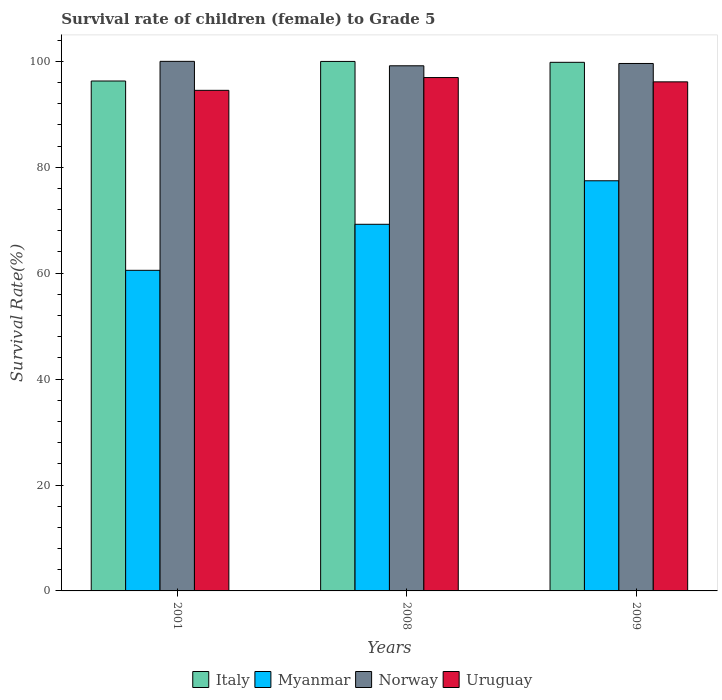How many groups of bars are there?
Your answer should be compact. 3. Are the number of bars per tick equal to the number of legend labels?
Keep it short and to the point. Yes. How many bars are there on the 2nd tick from the left?
Offer a very short reply. 4. How many bars are there on the 1st tick from the right?
Provide a succinct answer. 4. What is the label of the 3rd group of bars from the left?
Ensure brevity in your answer.  2009. In how many cases, is the number of bars for a given year not equal to the number of legend labels?
Provide a short and direct response. 0. What is the survival rate of female children to grade 5 in Uruguay in 2009?
Provide a short and direct response. 96.13. Across all years, what is the maximum survival rate of female children to grade 5 in Italy?
Your answer should be compact. 99.99. Across all years, what is the minimum survival rate of female children to grade 5 in Italy?
Keep it short and to the point. 96.29. In which year was the survival rate of female children to grade 5 in Myanmar maximum?
Your answer should be compact. 2009. In which year was the survival rate of female children to grade 5 in Uruguay minimum?
Ensure brevity in your answer.  2001. What is the total survival rate of female children to grade 5 in Italy in the graph?
Your response must be concise. 296.09. What is the difference between the survival rate of female children to grade 5 in Uruguay in 2001 and that in 2008?
Give a very brief answer. -2.41. What is the difference between the survival rate of female children to grade 5 in Norway in 2008 and the survival rate of female children to grade 5 in Uruguay in 2009?
Give a very brief answer. 3.04. What is the average survival rate of female children to grade 5 in Norway per year?
Give a very brief answer. 99.59. In the year 2001, what is the difference between the survival rate of female children to grade 5 in Italy and survival rate of female children to grade 5 in Uruguay?
Keep it short and to the point. 1.76. In how many years, is the survival rate of female children to grade 5 in Italy greater than 52 %?
Your answer should be very brief. 3. What is the ratio of the survival rate of female children to grade 5 in Italy in 2008 to that in 2009?
Offer a very short reply. 1. Is the survival rate of female children to grade 5 in Italy in 2008 less than that in 2009?
Your answer should be compact. No. Is the difference between the survival rate of female children to grade 5 in Italy in 2008 and 2009 greater than the difference between the survival rate of female children to grade 5 in Uruguay in 2008 and 2009?
Your answer should be very brief. No. What is the difference between the highest and the second highest survival rate of female children to grade 5 in Italy?
Provide a succinct answer. 0.17. What is the difference between the highest and the lowest survival rate of female children to grade 5 in Norway?
Your answer should be compact. 0.84. Is the sum of the survival rate of female children to grade 5 in Norway in 2001 and 2008 greater than the maximum survival rate of female children to grade 5 in Italy across all years?
Provide a short and direct response. Yes. What does the 2nd bar from the left in 2008 represents?
Your answer should be compact. Myanmar. What does the 4th bar from the right in 2009 represents?
Ensure brevity in your answer.  Italy. Is it the case that in every year, the sum of the survival rate of female children to grade 5 in Uruguay and survival rate of female children to grade 5 in Norway is greater than the survival rate of female children to grade 5 in Myanmar?
Offer a terse response. Yes. How many bars are there?
Your answer should be very brief. 12. Where does the legend appear in the graph?
Your response must be concise. Bottom center. How are the legend labels stacked?
Keep it short and to the point. Horizontal. What is the title of the graph?
Make the answer very short. Survival rate of children (female) to Grade 5. What is the label or title of the Y-axis?
Make the answer very short. Survival Rate(%). What is the Survival Rate(%) in Italy in 2001?
Your answer should be compact. 96.29. What is the Survival Rate(%) in Myanmar in 2001?
Provide a succinct answer. 60.54. What is the Survival Rate(%) in Uruguay in 2001?
Keep it short and to the point. 94.53. What is the Survival Rate(%) in Italy in 2008?
Offer a terse response. 99.99. What is the Survival Rate(%) in Myanmar in 2008?
Your answer should be very brief. 69.23. What is the Survival Rate(%) in Norway in 2008?
Give a very brief answer. 99.16. What is the Survival Rate(%) in Uruguay in 2008?
Offer a terse response. 96.94. What is the Survival Rate(%) in Italy in 2009?
Keep it short and to the point. 99.82. What is the Survival Rate(%) of Myanmar in 2009?
Your answer should be very brief. 77.45. What is the Survival Rate(%) of Norway in 2009?
Keep it short and to the point. 99.6. What is the Survival Rate(%) of Uruguay in 2009?
Your answer should be very brief. 96.13. Across all years, what is the maximum Survival Rate(%) of Italy?
Offer a terse response. 99.99. Across all years, what is the maximum Survival Rate(%) in Myanmar?
Keep it short and to the point. 77.45. Across all years, what is the maximum Survival Rate(%) in Norway?
Offer a terse response. 100. Across all years, what is the maximum Survival Rate(%) in Uruguay?
Your response must be concise. 96.94. Across all years, what is the minimum Survival Rate(%) in Italy?
Provide a short and direct response. 96.29. Across all years, what is the minimum Survival Rate(%) of Myanmar?
Your answer should be very brief. 60.54. Across all years, what is the minimum Survival Rate(%) in Norway?
Offer a terse response. 99.16. Across all years, what is the minimum Survival Rate(%) in Uruguay?
Make the answer very short. 94.53. What is the total Survival Rate(%) of Italy in the graph?
Make the answer very short. 296.09. What is the total Survival Rate(%) of Myanmar in the graph?
Your answer should be very brief. 207.22. What is the total Survival Rate(%) in Norway in the graph?
Your response must be concise. 298.76. What is the total Survival Rate(%) of Uruguay in the graph?
Your answer should be compact. 287.59. What is the difference between the Survival Rate(%) of Italy in 2001 and that in 2008?
Provide a short and direct response. -3.7. What is the difference between the Survival Rate(%) of Myanmar in 2001 and that in 2008?
Offer a terse response. -8.69. What is the difference between the Survival Rate(%) of Norway in 2001 and that in 2008?
Offer a very short reply. 0.84. What is the difference between the Survival Rate(%) in Uruguay in 2001 and that in 2008?
Give a very brief answer. -2.41. What is the difference between the Survival Rate(%) of Italy in 2001 and that in 2009?
Give a very brief answer. -3.53. What is the difference between the Survival Rate(%) in Myanmar in 2001 and that in 2009?
Make the answer very short. -16.91. What is the difference between the Survival Rate(%) of Norway in 2001 and that in 2009?
Offer a very short reply. 0.4. What is the difference between the Survival Rate(%) of Uruguay in 2001 and that in 2009?
Make the answer very short. -1.6. What is the difference between the Survival Rate(%) in Italy in 2008 and that in 2009?
Give a very brief answer. 0.17. What is the difference between the Survival Rate(%) in Myanmar in 2008 and that in 2009?
Offer a very short reply. -8.22. What is the difference between the Survival Rate(%) of Norway in 2008 and that in 2009?
Offer a terse response. -0.44. What is the difference between the Survival Rate(%) in Uruguay in 2008 and that in 2009?
Your answer should be compact. 0.81. What is the difference between the Survival Rate(%) in Italy in 2001 and the Survival Rate(%) in Myanmar in 2008?
Offer a very short reply. 27.06. What is the difference between the Survival Rate(%) in Italy in 2001 and the Survival Rate(%) in Norway in 2008?
Provide a short and direct response. -2.88. What is the difference between the Survival Rate(%) of Italy in 2001 and the Survival Rate(%) of Uruguay in 2008?
Provide a succinct answer. -0.65. What is the difference between the Survival Rate(%) of Myanmar in 2001 and the Survival Rate(%) of Norway in 2008?
Your answer should be compact. -38.62. What is the difference between the Survival Rate(%) of Myanmar in 2001 and the Survival Rate(%) of Uruguay in 2008?
Provide a succinct answer. -36.4. What is the difference between the Survival Rate(%) in Norway in 2001 and the Survival Rate(%) in Uruguay in 2008?
Offer a very short reply. 3.06. What is the difference between the Survival Rate(%) in Italy in 2001 and the Survival Rate(%) in Myanmar in 2009?
Your answer should be compact. 18.84. What is the difference between the Survival Rate(%) of Italy in 2001 and the Survival Rate(%) of Norway in 2009?
Your response must be concise. -3.31. What is the difference between the Survival Rate(%) of Italy in 2001 and the Survival Rate(%) of Uruguay in 2009?
Offer a terse response. 0.16. What is the difference between the Survival Rate(%) in Myanmar in 2001 and the Survival Rate(%) in Norway in 2009?
Offer a terse response. -39.06. What is the difference between the Survival Rate(%) in Myanmar in 2001 and the Survival Rate(%) in Uruguay in 2009?
Provide a succinct answer. -35.59. What is the difference between the Survival Rate(%) in Norway in 2001 and the Survival Rate(%) in Uruguay in 2009?
Make the answer very short. 3.87. What is the difference between the Survival Rate(%) in Italy in 2008 and the Survival Rate(%) in Myanmar in 2009?
Keep it short and to the point. 22.54. What is the difference between the Survival Rate(%) in Italy in 2008 and the Survival Rate(%) in Norway in 2009?
Provide a short and direct response. 0.39. What is the difference between the Survival Rate(%) of Italy in 2008 and the Survival Rate(%) of Uruguay in 2009?
Offer a terse response. 3.86. What is the difference between the Survival Rate(%) of Myanmar in 2008 and the Survival Rate(%) of Norway in 2009?
Ensure brevity in your answer.  -30.37. What is the difference between the Survival Rate(%) of Myanmar in 2008 and the Survival Rate(%) of Uruguay in 2009?
Offer a very short reply. -26.9. What is the difference between the Survival Rate(%) of Norway in 2008 and the Survival Rate(%) of Uruguay in 2009?
Give a very brief answer. 3.04. What is the average Survival Rate(%) of Italy per year?
Ensure brevity in your answer.  98.7. What is the average Survival Rate(%) in Myanmar per year?
Make the answer very short. 69.07. What is the average Survival Rate(%) in Norway per year?
Offer a very short reply. 99.59. What is the average Survival Rate(%) of Uruguay per year?
Your answer should be very brief. 95.86. In the year 2001, what is the difference between the Survival Rate(%) of Italy and Survival Rate(%) of Myanmar?
Your answer should be very brief. 35.75. In the year 2001, what is the difference between the Survival Rate(%) in Italy and Survival Rate(%) in Norway?
Offer a terse response. -3.71. In the year 2001, what is the difference between the Survival Rate(%) in Italy and Survival Rate(%) in Uruguay?
Ensure brevity in your answer.  1.76. In the year 2001, what is the difference between the Survival Rate(%) in Myanmar and Survival Rate(%) in Norway?
Offer a very short reply. -39.46. In the year 2001, what is the difference between the Survival Rate(%) in Myanmar and Survival Rate(%) in Uruguay?
Offer a terse response. -33.99. In the year 2001, what is the difference between the Survival Rate(%) in Norway and Survival Rate(%) in Uruguay?
Make the answer very short. 5.47. In the year 2008, what is the difference between the Survival Rate(%) in Italy and Survival Rate(%) in Myanmar?
Offer a very short reply. 30.75. In the year 2008, what is the difference between the Survival Rate(%) of Italy and Survival Rate(%) of Norway?
Provide a short and direct response. 0.82. In the year 2008, what is the difference between the Survival Rate(%) in Italy and Survival Rate(%) in Uruguay?
Offer a terse response. 3.05. In the year 2008, what is the difference between the Survival Rate(%) of Myanmar and Survival Rate(%) of Norway?
Give a very brief answer. -29.93. In the year 2008, what is the difference between the Survival Rate(%) in Myanmar and Survival Rate(%) in Uruguay?
Your answer should be very brief. -27.71. In the year 2008, what is the difference between the Survival Rate(%) of Norway and Survival Rate(%) of Uruguay?
Offer a very short reply. 2.22. In the year 2009, what is the difference between the Survival Rate(%) in Italy and Survival Rate(%) in Myanmar?
Your answer should be very brief. 22.37. In the year 2009, what is the difference between the Survival Rate(%) of Italy and Survival Rate(%) of Norway?
Your response must be concise. 0.22. In the year 2009, what is the difference between the Survival Rate(%) of Italy and Survival Rate(%) of Uruguay?
Give a very brief answer. 3.69. In the year 2009, what is the difference between the Survival Rate(%) of Myanmar and Survival Rate(%) of Norway?
Offer a very short reply. -22.15. In the year 2009, what is the difference between the Survival Rate(%) of Myanmar and Survival Rate(%) of Uruguay?
Offer a terse response. -18.68. In the year 2009, what is the difference between the Survival Rate(%) in Norway and Survival Rate(%) in Uruguay?
Offer a terse response. 3.47. What is the ratio of the Survival Rate(%) in Myanmar in 2001 to that in 2008?
Your answer should be very brief. 0.87. What is the ratio of the Survival Rate(%) of Norway in 2001 to that in 2008?
Give a very brief answer. 1.01. What is the ratio of the Survival Rate(%) in Uruguay in 2001 to that in 2008?
Offer a terse response. 0.98. What is the ratio of the Survival Rate(%) in Italy in 2001 to that in 2009?
Your answer should be compact. 0.96. What is the ratio of the Survival Rate(%) in Myanmar in 2001 to that in 2009?
Ensure brevity in your answer.  0.78. What is the ratio of the Survival Rate(%) of Uruguay in 2001 to that in 2009?
Give a very brief answer. 0.98. What is the ratio of the Survival Rate(%) in Myanmar in 2008 to that in 2009?
Give a very brief answer. 0.89. What is the ratio of the Survival Rate(%) in Uruguay in 2008 to that in 2009?
Give a very brief answer. 1.01. What is the difference between the highest and the second highest Survival Rate(%) of Italy?
Your response must be concise. 0.17. What is the difference between the highest and the second highest Survival Rate(%) in Myanmar?
Offer a terse response. 8.22. What is the difference between the highest and the second highest Survival Rate(%) in Norway?
Your answer should be very brief. 0.4. What is the difference between the highest and the second highest Survival Rate(%) of Uruguay?
Ensure brevity in your answer.  0.81. What is the difference between the highest and the lowest Survival Rate(%) of Italy?
Your answer should be very brief. 3.7. What is the difference between the highest and the lowest Survival Rate(%) of Myanmar?
Offer a very short reply. 16.91. What is the difference between the highest and the lowest Survival Rate(%) of Norway?
Your answer should be compact. 0.84. What is the difference between the highest and the lowest Survival Rate(%) in Uruguay?
Offer a terse response. 2.41. 